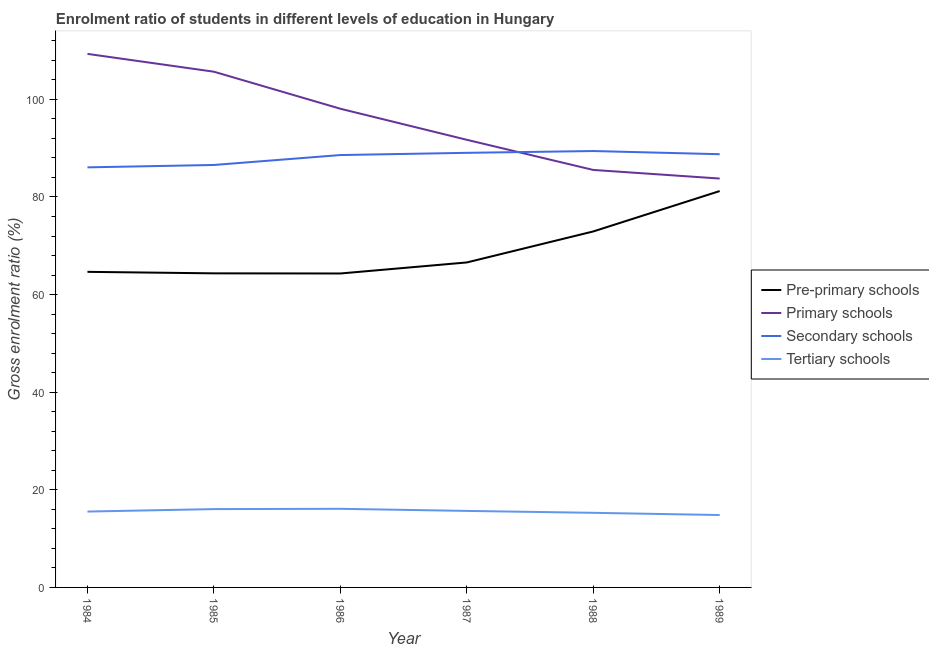Does the line corresponding to gross enrolment ratio in pre-primary schools intersect with the line corresponding to gross enrolment ratio in secondary schools?
Provide a succinct answer. No. Is the number of lines equal to the number of legend labels?
Provide a succinct answer. Yes. What is the gross enrolment ratio in tertiary schools in 1987?
Make the answer very short. 15.68. Across all years, what is the maximum gross enrolment ratio in secondary schools?
Offer a terse response. 89.41. Across all years, what is the minimum gross enrolment ratio in tertiary schools?
Offer a very short reply. 14.83. In which year was the gross enrolment ratio in tertiary schools maximum?
Your answer should be very brief. 1986. In which year was the gross enrolment ratio in secondary schools minimum?
Ensure brevity in your answer.  1984. What is the total gross enrolment ratio in secondary schools in the graph?
Give a very brief answer. 528.42. What is the difference between the gross enrolment ratio in tertiary schools in 1985 and that in 1987?
Provide a succinct answer. 0.37. What is the difference between the gross enrolment ratio in pre-primary schools in 1988 and the gross enrolment ratio in secondary schools in 1986?
Keep it short and to the point. -15.66. What is the average gross enrolment ratio in secondary schools per year?
Provide a succinct answer. 88.07. In the year 1988, what is the difference between the gross enrolment ratio in pre-primary schools and gross enrolment ratio in secondary schools?
Provide a short and direct response. -16.48. What is the ratio of the gross enrolment ratio in tertiary schools in 1986 to that in 1988?
Offer a very short reply. 1.05. Is the difference between the gross enrolment ratio in secondary schools in 1986 and 1988 greater than the difference between the gross enrolment ratio in tertiary schools in 1986 and 1988?
Offer a very short reply. No. What is the difference between the highest and the second highest gross enrolment ratio in pre-primary schools?
Provide a short and direct response. 8.28. What is the difference between the highest and the lowest gross enrolment ratio in tertiary schools?
Ensure brevity in your answer.  1.28. Is the sum of the gross enrolment ratio in tertiary schools in 1985 and 1988 greater than the maximum gross enrolment ratio in primary schools across all years?
Keep it short and to the point. No. Is it the case that in every year, the sum of the gross enrolment ratio in pre-primary schools and gross enrolment ratio in tertiary schools is greater than the sum of gross enrolment ratio in primary schools and gross enrolment ratio in secondary schools?
Your answer should be compact. Yes. Is it the case that in every year, the sum of the gross enrolment ratio in pre-primary schools and gross enrolment ratio in primary schools is greater than the gross enrolment ratio in secondary schools?
Provide a succinct answer. Yes. Does the gross enrolment ratio in secondary schools monotonically increase over the years?
Provide a succinct answer. No. Is the gross enrolment ratio in secondary schools strictly less than the gross enrolment ratio in tertiary schools over the years?
Provide a succinct answer. No. How many years are there in the graph?
Your answer should be very brief. 6. Does the graph contain any zero values?
Offer a very short reply. No. How many legend labels are there?
Provide a succinct answer. 4. What is the title of the graph?
Offer a very short reply. Enrolment ratio of students in different levels of education in Hungary. Does "France" appear as one of the legend labels in the graph?
Your answer should be compact. No. What is the label or title of the X-axis?
Offer a very short reply. Year. What is the Gross enrolment ratio (%) of Pre-primary schools in 1984?
Keep it short and to the point. 64.66. What is the Gross enrolment ratio (%) of Primary schools in 1984?
Offer a terse response. 109.31. What is the Gross enrolment ratio (%) of Secondary schools in 1984?
Offer a terse response. 86.07. What is the Gross enrolment ratio (%) of Tertiary schools in 1984?
Your response must be concise. 15.54. What is the Gross enrolment ratio (%) in Pre-primary schools in 1985?
Your response must be concise. 64.35. What is the Gross enrolment ratio (%) in Primary schools in 1985?
Ensure brevity in your answer.  105.66. What is the Gross enrolment ratio (%) of Secondary schools in 1985?
Ensure brevity in your answer.  86.55. What is the Gross enrolment ratio (%) in Tertiary schools in 1985?
Offer a terse response. 16.05. What is the Gross enrolment ratio (%) in Pre-primary schools in 1986?
Provide a succinct answer. 64.32. What is the Gross enrolment ratio (%) in Primary schools in 1986?
Offer a very short reply. 98.08. What is the Gross enrolment ratio (%) of Secondary schools in 1986?
Your answer should be compact. 88.59. What is the Gross enrolment ratio (%) of Tertiary schools in 1986?
Ensure brevity in your answer.  16.11. What is the Gross enrolment ratio (%) in Pre-primary schools in 1987?
Keep it short and to the point. 66.58. What is the Gross enrolment ratio (%) in Primary schools in 1987?
Give a very brief answer. 91.71. What is the Gross enrolment ratio (%) in Secondary schools in 1987?
Your answer should be compact. 89.04. What is the Gross enrolment ratio (%) of Tertiary schools in 1987?
Your response must be concise. 15.68. What is the Gross enrolment ratio (%) in Pre-primary schools in 1988?
Your answer should be compact. 72.93. What is the Gross enrolment ratio (%) of Primary schools in 1988?
Offer a terse response. 85.54. What is the Gross enrolment ratio (%) of Secondary schools in 1988?
Give a very brief answer. 89.41. What is the Gross enrolment ratio (%) in Tertiary schools in 1988?
Provide a succinct answer. 15.29. What is the Gross enrolment ratio (%) in Pre-primary schools in 1989?
Your response must be concise. 81.21. What is the Gross enrolment ratio (%) of Primary schools in 1989?
Offer a terse response. 83.77. What is the Gross enrolment ratio (%) of Secondary schools in 1989?
Your answer should be compact. 88.76. What is the Gross enrolment ratio (%) in Tertiary schools in 1989?
Give a very brief answer. 14.83. Across all years, what is the maximum Gross enrolment ratio (%) of Pre-primary schools?
Ensure brevity in your answer.  81.21. Across all years, what is the maximum Gross enrolment ratio (%) in Primary schools?
Ensure brevity in your answer.  109.31. Across all years, what is the maximum Gross enrolment ratio (%) in Secondary schools?
Provide a succinct answer. 89.41. Across all years, what is the maximum Gross enrolment ratio (%) of Tertiary schools?
Make the answer very short. 16.11. Across all years, what is the minimum Gross enrolment ratio (%) of Pre-primary schools?
Your response must be concise. 64.32. Across all years, what is the minimum Gross enrolment ratio (%) in Primary schools?
Make the answer very short. 83.77. Across all years, what is the minimum Gross enrolment ratio (%) in Secondary schools?
Your answer should be compact. 86.07. Across all years, what is the minimum Gross enrolment ratio (%) in Tertiary schools?
Offer a very short reply. 14.83. What is the total Gross enrolment ratio (%) of Pre-primary schools in the graph?
Give a very brief answer. 414.05. What is the total Gross enrolment ratio (%) in Primary schools in the graph?
Provide a short and direct response. 574.07. What is the total Gross enrolment ratio (%) in Secondary schools in the graph?
Offer a very short reply. 528.42. What is the total Gross enrolment ratio (%) in Tertiary schools in the graph?
Your answer should be very brief. 93.5. What is the difference between the Gross enrolment ratio (%) of Pre-primary schools in 1984 and that in 1985?
Give a very brief answer. 0.31. What is the difference between the Gross enrolment ratio (%) of Primary schools in 1984 and that in 1985?
Make the answer very short. 3.65. What is the difference between the Gross enrolment ratio (%) of Secondary schools in 1984 and that in 1985?
Give a very brief answer. -0.49. What is the difference between the Gross enrolment ratio (%) in Tertiary schools in 1984 and that in 1985?
Keep it short and to the point. -0.5. What is the difference between the Gross enrolment ratio (%) of Pre-primary schools in 1984 and that in 1986?
Give a very brief answer. 0.34. What is the difference between the Gross enrolment ratio (%) of Primary schools in 1984 and that in 1986?
Provide a short and direct response. 11.24. What is the difference between the Gross enrolment ratio (%) of Secondary schools in 1984 and that in 1986?
Keep it short and to the point. -2.52. What is the difference between the Gross enrolment ratio (%) of Tertiary schools in 1984 and that in 1986?
Your response must be concise. -0.56. What is the difference between the Gross enrolment ratio (%) of Pre-primary schools in 1984 and that in 1987?
Your response must be concise. -1.92. What is the difference between the Gross enrolment ratio (%) of Primary schools in 1984 and that in 1987?
Give a very brief answer. 17.6. What is the difference between the Gross enrolment ratio (%) in Secondary schools in 1984 and that in 1987?
Provide a short and direct response. -2.98. What is the difference between the Gross enrolment ratio (%) of Tertiary schools in 1984 and that in 1987?
Offer a terse response. -0.14. What is the difference between the Gross enrolment ratio (%) of Pre-primary schools in 1984 and that in 1988?
Keep it short and to the point. -8.27. What is the difference between the Gross enrolment ratio (%) of Primary schools in 1984 and that in 1988?
Your answer should be compact. 23.78. What is the difference between the Gross enrolment ratio (%) in Secondary schools in 1984 and that in 1988?
Your response must be concise. -3.34. What is the difference between the Gross enrolment ratio (%) in Tertiary schools in 1984 and that in 1988?
Give a very brief answer. 0.26. What is the difference between the Gross enrolment ratio (%) in Pre-primary schools in 1984 and that in 1989?
Your answer should be very brief. -16.55. What is the difference between the Gross enrolment ratio (%) in Primary schools in 1984 and that in 1989?
Provide a succinct answer. 25.54. What is the difference between the Gross enrolment ratio (%) of Secondary schools in 1984 and that in 1989?
Your answer should be compact. -2.69. What is the difference between the Gross enrolment ratio (%) in Tertiary schools in 1984 and that in 1989?
Keep it short and to the point. 0.71. What is the difference between the Gross enrolment ratio (%) in Pre-primary schools in 1985 and that in 1986?
Give a very brief answer. 0.03. What is the difference between the Gross enrolment ratio (%) of Primary schools in 1985 and that in 1986?
Make the answer very short. 7.59. What is the difference between the Gross enrolment ratio (%) of Secondary schools in 1985 and that in 1986?
Keep it short and to the point. -2.03. What is the difference between the Gross enrolment ratio (%) of Tertiary schools in 1985 and that in 1986?
Give a very brief answer. -0.06. What is the difference between the Gross enrolment ratio (%) of Pre-primary schools in 1985 and that in 1987?
Your answer should be compact. -2.23. What is the difference between the Gross enrolment ratio (%) of Primary schools in 1985 and that in 1987?
Make the answer very short. 13.95. What is the difference between the Gross enrolment ratio (%) of Secondary schools in 1985 and that in 1987?
Offer a terse response. -2.49. What is the difference between the Gross enrolment ratio (%) of Tertiary schools in 1985 and that in 1987?
Offer a terse response. 0.37. What is the difference between the Gross enrolment ratio (%) in Pre-primary schools in 1985 and that in 1988?
Offer a terse response. -8.58. What is the difference between the Gross enrolment ratio (%) of Primary schools in 1985 and that in 1988?
Ensure brevity in your answer.  20.13. What is the difference between the Gross enrolment ratio (%) in Secondary schools in 1985 and that in 1988?
Provide a succinct answer. -2.86. What is the difference between the Gross enrolment ratio (%) of Tertiary schools in 1985 and that in 1988?
Your answer should be compact. 0.76. What is the difference between the Gross enrolment ratio (%) of Pre-primary schools in 1985 and that in 1989?
Provide a short and direct response. -16.86. What is the difference between the Gross enrolment ratio (%) in Primary schools in 1985 and that in 1989?
Offer a terse response. 21.89. What is the difference between the Gross enrolment ratio (%) of Secondary schools in 1985 and that in 1989?
Provide a short and direct response. -2.2. What is the difference between the Gross enrolment ratio (%) in Tertiary schools in 1985 and that in 1989?
Your answer should be very brief. 1.22. What is the difference between the Gross enrolment ratio (%) in Pre-primary schools in 1986 and that in 1987?
Ensure brevity in your answer.  -2.26. What is the difference between the Gross enrolment ratio (%) of Primary schools in 1986 and that in 1987?
Give a very brief answer. 6.36. What is the difference between the Gross enrolment ratio (%) of Secondary schools in 1986 and that in 1987?
Provide a succinct answer. -0.46. What is the difference between the Gross enrolment ratio (%) in Tertiary schools in 1986 and that in 1987?
Your answer should be very brief. 0.43. What is the difference between the Gross enrolment ratio (%) of Pre-primary schools in 1986 and that in 1988?
Make the answer very short. -8.61. What is the difference between the Gross enrolment ratio (%) in Primary schools in 1986 and that in 1988?
Give a very brief answer. 12.54. What is the difference between the Gross enrolment ratio (%) in Secondary schools in 1986 and that in 1988?
Provide a short and direct response. -0.82. What is the difference between the Gross enrolment ratio (%) of Tertiary schools in 1986 and that in 1988?
Ensure brevity in your answer.  0.82. What is the difference between the Gross enrolment ratio (%) of Pre-primary schools in 1986 and that in 1989?
Your answer should be compact. -16.89. What is the difference between the Gross enrolment ratio (%) in Primary schools in 1986 and that in 1989?
Make the answer very short. 14.3. What is the difference between the Gross enrolment ratio (%) of Secondary schools in 1986 and that in 1989?
Provide a short and direct response. -0.17. What is the difference between the Gross enrolment ratio (%) in Tertiary schools in 1986 and that in 1989?
Your answer should be compact. 1.28. What is the difference between the Gross enrolment ratio (%) of Pre-primary schools in 1987 and that in 1988?
Provide a succinct answer. -6.35. What is the difference between the Gross enrolment ratio (%) of Primary schools in 1987 and that in 1988?
Your response must be concise. 6.17. What is the difference between the Gross enrolment ratio (%) of Secondary schools in 1987 and that in 1988?
Your response must be concise. -0.37. What is the difference between the Gross enrolment ratio (%) in Tertiary schools in 1987 and that in 1988?
Give a very brief answer. 0.39. What is the difference between the Gross enrolment ratio (%) of Pre-primary schools in 1987 and that in 1989?
Offer a terse response. -14.63. What is the difference between the Gross enrolment ratio (%) of Primary schools in 1987 and that in 1989?
Make the answer very short. 7.94. What is the difference between the Gross enrolment ratio (%) of Secondary schools in 1987 and that in 1989?
Your answer should be compact. 0.28. What is the difference between the Gross enrolment ratio (%) in Tertiary schools in 1987 and that in 1989?
Ensure brevity in your answer.  0.85. What is the difference between the Gross enrolment ratio (%) of Pre-primary schools in 1988 and that in 1989?
Provide a short and direct response. -8.28. What is the difference between the Gross enrolment ratio (%) in Primary schools in 1988 and that in 1989?
Make the answer very short. 1.76. What is the difference between the Gross enrolment ratio (%) in Secondary schools in 1988 and that in 1989?
Provide a short and direct response. 0.65. What is the difference between the Gross enrolment ratio (%) in Tertiary schools in 1988 and that in 1989?
Provide a short and direct response. 0.46. What is the difference between the Gross enrolment ratio (%) of Pre-primary schools in 1984 and the Gross enrolment ratio (%) of Primary schools in 1985?
Your answer should be very brief. -41. What is the difference between the Gross enrolment ratio (%) in Pre-primary schools in 1984 and the Gross enrolment ratio (%) in Secondary schools in 1985?
Keep it short and to the point. -21.9. What is the difference between the Gross enrolment ratio (%) of Pre-primary schools in 1984 and the Gross enrolment ratio (%) of Tertiary schools in 1985?
Your response must be concise. 48.61. What is the difference between the Gross enrolment ratio (%) of Primary schools in 1984 and the Gross enrolment ratio (%) of Secondary schools in 1985?
Your response must be concise. 22.76. What is the difference between the Gross enrolment ratio (%) of Primary schools in 1984 and the Gross enrolment ratio (%) of Tertiary schools in 1985?
Provide a short and direct response. 93.27. What is the difference between the Gross enrolment ratio (%) of Secondary schools in 1984 and the Gross enrolment ratio (%) of Tertiary schools in 1985?
Your response must be concise. 70.02. What is the difference between the Gross enrolment ratio (%) in Pre-primary schools in 1984 and the Gross enrolment ratio (%) in Primary schools in 1986?
Provide a succinct answer. -33.42. What is the difference between the Gross enrolment ratio (%) in Pre-primary schools in 1984 and the Gross enrolment ratio (%) in Secondary schools in 1986?
Keep it short and to the point. -23.93. What is the difference between the Gross enrolment ratio (%) in Pre-primary schools in 1984 and the Gross enrolment ratio (%) in Tertiary schools in 1986?
Your response must be concise. 48.55. What is the difference between the Gross enrolment ratio (%) of Primary schools in 1984 and the Gross enrolment ratio (%) of Secondary schools in 1986?
Keep it short and to the point. 20.73. What is the difference between the Gross enrolment ratio (%) in Primary schools in 1984 and the Gross enrolment ratio (%) in Tertiary schools in 1986?
Your response must be concise. 93.21. What is the difference between the Gross enrolment ratio (%) of Secondary schools in 1984 and the Gross enrolment ratio (%) of Tertiary schools in 1986?
Ensure brevity in your answer.  69.96. What is the difference between the Gross enrolment ratio (%) in Pre-primary schools in 1984 and the Gross enrolment ratio (%) in Primary schools in 1987?
Keep it short and to the point. -27.05. What is the difference between the Gross enrolment ratio (%) of Pre-primary schools in 1984 and the Gross enrolment ratio (%) of Secondary schools in 1987?
Provide a short and direct response. -24.38. What is the difference between the Gross enrolment ratio (%) in Pre-primary schools in 1984 and the Gross enrolment ratio (%) in Tertiary schools in 1987?
Your answer should be compact. 48.98. What is the difference between the Gross enrolment ratio (%) of Primary schools in 1984 and the Gross enrolment ratio (%) of Secondary schools in 1987?
Offer a very short reply. 20.27. What is the difference between the Gross enrolment ratio (%) of Primary schools in 1984 and the Gross enrolment ratio (%) of Tertiary schools in 1987?
Provide a succinct answer. 93.64. What is the difference between the Gross enrolment ratio (%) of Secondary schools in 1984 and the Gross enrolment ratio (%) of Tertiary schools in 1987?
Offer a very short reply. 70.39. What is the difference between the Gross enrolment ratio (%) of Pre-primary schools in 1984 and the Gross enrolment ratio (%) of Primary schools in 1988?
Your response must be concise. -20.88. What is the difference between the Gross enrolment ratio (%) of Pre-primary schools in 1984 and the Gross enrolment ratio (%) of Secondary schools in 1988?
Provide a short and direct response. -24.75. What is the difference between the Gross enrolment ratio (%) of Pre-primary schools in 1984 and the Gross enrolment ratio (%) of Tertiary schools in 1988?
Your response must be concise. 49.37. What is the difference between the Gross enrolment ratio (%) in Primary schools in 1984 and the Gross enrolment ratio (%) in Secondary schools in 1988?
Your answer should be compact. 19.9. What is the difference between the Gross enrolment ratio (%) of Primary schools in 1984 and the Gross enrolment ratio (%) of Tertiary schools in 1988?
Provide a short and direct response. 94.03. What is the difference between the Gross enrolment ratio (%) in Secondary schools in 1984 and the Gross enrolment ratio (%) in Tertiary schools in 1988?
Your answer should be very brief. 70.78. What is the difference between the Gross enrolment ratio (%) in Pre-primary schools in 1984 and the Gross enrolment ratio (%) in Primary schools in 1989?
Provide a succinct answer. -19.11. What is the difference between the Gross enrolment ratio (%) of Pre-primary schools in 1984 and the Gross enrolment ratio (%) of Secondary schools in 1989?
Your response must be concise. -24.1. What is the difference between the Gross enrolment ratio (%) of Pre-primary schools in 1984 and the Gross enrolment ratio (%) of Tertiary schools in 1989?
Offer a terse response. 49.83. What is the difference between the Gross enrolment ratio (%) of Primary schools in 1984 and the Gross enrolment ratio (%) of Secondary schools in 1989?
Ensure brevity in your answer.  20.56. What is the difference between the Gross enrolment ratio (%) of Primary schools in 1984 and the Gross enrolment ratio (%) of Tertiary schools in 1989?
Provide a succinct answer. 94.48. What is the difference between the Gross enrolment ratio (%) of Secondary schools in 1984 and the Gross enrolment ratio (%) of Tertiary schools in 1989?
Ensure brevity in your answer.  71.24. What is the difference between the Gross enrolment ratio (%) of Pre-primary schools in 1985 and the Gross enrolment ratio (%) of Primary schools in 1986?
Provide a short and direct response. -33.73. What is the difference between the Gross enrolment ratio (%) of Pre-primary schools in 1985 and the Gross enrolment ratio (%) of Secondary schools in 1986?
Provide a short and direct response. -24.24. What is the difference between the Gross enrolment ratio (%) of Pre-primary schools in 1985 and the Gross enrolment ratio (%) of Tertiary schools in 1986?
Ensure brevity in your answer.  48.24. What is the difference between the Gross enrolment ratio (%) in Primary schools in 1985 and the Gross enrolment ratio (%) in Secondary schools in 1986?
Your response must be concise. 17.08. What is the difference between the Gross enrolment ratio (%) in Primary schools in 1985 and the Gross enrolment ratio (%) in Tertiary schools in 1986?
Your answer should be very brief. 89.56. What is the difference between the Gross enrolment ratio (%) in Secondary schools in 1985 and the Gross enrolment ratio (%) in Tertiary schools in 1986?
Provide a short and direct response. 70.45. What is the difference between the Gross enrolment ratio (%) of Pre-primary schools in 1985 and the Gross enrolment ratio (%) of Primary schools in 1987?
Provide a succinct answer. -27.36. What is the difference between the Gross enrolment ratio (%) in Pre-primary schools in 1985 and the Gross enrolment ratio (%) in Secondary schools in 1987?
Your answer should be compact. -24.69. What is the difference between the Gross enrolment ratio (%) in Pre-primary schools in 1985 and the Gross enrolment ratio (%) in Tertiary schools in 1987?
Offer a terse response. 48.67. What is the difference between the Gross enrolment ratio (%) of Primary schools in 1985 and the Gross enrolment ratio (%) of Secondary schools in 1987?
Your answer should be compact. 16.62. What is the difference between the Gross enrolment ratio (%) in Primary schools in 1985 and the Gross enrolment ratio (%) in Tertiary schools in 1987?
Offer a very short reply. 89.98. What is the difference between the Gross enrolment ratio (%) in Secondary schools in 1985 and the Gross enrolment ratio (%) in Tertiary schools in 1987?
Offer a very short reply. 70.88. What is the difference between the Gross enrolment ratio (%) in Pre-primary schools in 1985 and the Gross enrolment ratio (%) in Primary schools in 1988?
Ensure brevity in your answer.  -21.19. What is the difference between the Gross enrolment ratio (%) in Pre-primary schools in 1985 and the Gross enrolment ratio (%) in Secondary schools in 1988?
Make the answer very short. -25.06. What is the difference between the Gross enrolment ratio (%) in Pre-primary schools in 1985 and the Gross enrolment ratio (%) in Tertiary schools in 1988?
Your response must be concise. 49.06. What is the difference between the Gross enrolment ratio (%) in Primary schools in 1985 and the Gross enrolment ratio (%) in Secondary schools in 1988?
Your response must be concise. 16.25. What is the difference between the Gross enrolment ratio (%) of Primary schools in 1985 and the Gross enrolment ratio (%) of Tertiary schools in 1988?
Ensure brevity in your answer.  90.38. What is the difference between the Gross enrolment ratio (%) in Secondary schools in 1985 and the Gross enrolment ratio (%) in Tertiary schools in 1988?
Your answer should be compact. 71.27. What is the difference between the Gross enrolment ratio (%) in Pre-primary schools in 1985 and the Gross enrolment ratio (%) in Primary schools in 1989?
Your response must be concise. -19.42. What is the difference between the Gross enrolment ratio (%) in Pre-primary schools in 1985 and the Gross enrolment ratio (%) in Secondary schools in 1989?
Your answer should be very brief. -24.41. What is the difference between the Gross enrolment ratio (%) in Pre-primary schools in 1985 and the Gross enrolment ratio (%) in Tertiary schools in 1989?
Your response must be concise. 49.52. What is the difference between the Gross enrolment ratio (%) of Primary schools in 1985 and the Gross enrolment ratio (%) of Secondary schools in 1989?
Your answer should be very brief. 16.9. What is the difference between the Gross enrolment ratio (%) in Primary schools in 1985 and the Gross enrolment ratio (%) in Tertiary schools in 1989?
Offer a terse response. 90.83. What is the difference between the Gross enrolment ratio (%) of Secondary schools in 1985 and the Gross enrolment ratio (%) of Tertiary schools in 1989?
Provide a short and direct response. 71.72. What is the difference between the Gross enrolment ratio (%) of Pre-primary schools in 1986 and the Gross enrolment ratio (%) of Primary schools in 1987?
Your response must be concise. -27.39. What is the difference between the Gross enrolment ratio (%) of Pre-primary schools in 1986 and the Gross enrolment ratio (%) of Secondary schools in 1987?
Keep it short and to the point. -24.72. What is the difference between the Gross enrolment ratio (%) in Pre-primary schools in 1986 and the Gross enrolment ratio (%) in Tertiary schools in 1987?
Your response must be concise. 48.64. What is the difference between the Gross enrolment ratio (%) in Primary schools in 1986 and the Gross enrolment ratio (%) in Secondary schools in 1987?
Give a very brief answer. 9.03. What is the difference between the Gross enrolment ratio (%) in Primary schools in 1986 and the Gross enrolment ratio (%) in Tertiary schools in 1987?
Give a very brief answer. 82.4. What is the difference between the Gross enrolment ratio (%) in Secondary schools in 1986 and the Gross enrolment ratio (%) in Tertiary schools in 1987?
Make the answer very short. 72.91. What is the difference between the Gross enrolment ratio (%) of Pre-primary schools in 1986 and the Gross enrolment ratio (%) of Primary schools in 1988?
Offer a very short reply. -21.21. What is the difference between the Gross enrolment ratio (%) in Pre-primary schools in 1986 and the Gross enrolment ratio (%) in Secondary schools in 1988?
Give a very brief answer. -25.09. What is the difference between the Gross enrolment ratio (%) in Pre-primary schools in 1986 and the Gross enrolment ratio (%) in Tertiary schools in 1988?
Your response must be concise. 49.04. What is the difference between the Gross enrolment ratio (%) in Primary schools in 1986 and the Gross enrolment ratio (%) in Secondary schools in 1988?
Your answer should be compact. 8.67. What is the difference between the Gross enrolment ratio (%) of Primary schools in 1986 and the Gross enrolment ratio (%) of Tertiary schools in 1988?
Keep it short and to the point. 82.79. What is the difference between the Gross enrolment ratio (%) of Secondary schools in 1986 and the Gross enrolment ratio (%) of Tertiary schools in 1988?
Your answer should be compact. 73.3. What is the difference between the Gross enrolment ratio (%) of Pre-primary schools in 1986 and the Gross enrolment ratio (%) of Primary schools in 1989?
Keep it short and to the point. -19.45. What is the difference between the Gross enrolment ratio (%) in Pre-primary schools in 1986 and the Gross enrolment ratio (%) in Secondary schools in 1989?
Your answer should be very brief. -24.44. What is the difference between the Gross enrolment ratio (%) in Pre-primary schools in 1986 and the Gross enrolment ratio (%) in Tertiary schools in 1989?
Keep it short and to the point. 49.49. What is the difference between the Gross enrolment ratio (%) in Primary schools in 1986 and the Gross enrolment ratio (%) in Secondary schools in 1989?
Your answer should be compact. 9.32. What is the difference between the Gross enrolment ratio (%) in Primary schools in 1986 and the Gross enrolment ratio (%) in Tertiary schools in 1989?
Ensure brevity in your answer.  83.24. What is the difference between the Gross enrolment ratio (%) in Secondary schools in 1986 and the Gross enrolment ratio (%) in Tertiary schools in 1989?
Provide a succinct answer. 73.76. What is the difference between the Gross enrolment ratio (%) of Pre-primary schools in 1987 and the Gross enrolment ratio (%) of Primary schools in 1988?
Your answer should be compact. -18.95. What is the difference between the Gross enrolment ratio (%) in Pre-primary schools in 1987 and the Gross enrolment ratio (%) in Secondary schools in 1988?
Provide a succinct answer. -22.83. What is the difference between the Gross enrolment ratio (%) in Pre-primary schools in 1987 and the Gross enrolment ratio (%) in Tertiary schools in 1988?
Provide a succinct answer. 51.3. What is the difference between the Gross enrolment ratio (%) in Primary schools in 1987 and the Gross enrolment ratio (%) in Secondary schools in 1988?
Offer a terse response. 2.3. What is the difference between the Gross enrolment ratio (%) of Primary schools in 1987 and the Gross enrolment ratio (%) of Tertiary schools in 1988?
Offer a terse response. 76.42. What is the difference between the Gross enrolment ratio (%) in Secondary schools in 1987 and the Gross enrolment ratio (%) in Tertiary schools in 1988?
Your answer should be compact. 73.76. What is the difference between the Gross enrolment ratio (%) of Pre-primary schools in 1987 and the Gross enrolment ratio (%) of Primary schools in 1989?
Provide a succinct answer. -17.19. What is the difference between the Gross enrolment ratio (%) of Pre-primary schools in 1987 and the Gross enrolment ratio (%) of Secondary schools in 1989?
Make the answer very short. -22.18. What is the difference between the Gross enrolment ratio (%) of Pre-primary schools in 1987 and the Gross enrolment ratio (%) of Tertiary schools in 1989?
Offer a terse response. 51.75. What is the difference between the Gross enrolment ratio (%) of Primary schools in 1987 and the Gross enrolment ratio (%) of Secondary schools in 1989?
Your answer should be very brief. 2.95. What is the difference between the Gross enrolment ratio (%) of Primary schools in 1987 and the Gross enrolment ratio (%) of Tertiary schools in 1989?
Your answer should be very brief. 76.88. What is the difference between the Gross enrolment ratio (%) in Secondary schools in 1987 and the Gross enrolment ratio (%) in Tertiary schools in 1989?
Your response must be concise. 74.21. What is the difference between the Gross enrolment ratio (%) in Pre-primary schools in 1988 and the Gross enrolment ratio (%) in Primary schools in 1989?
Provide a succinct answer. -10.84. What is the difference between the Gross enrolment ratio (%) of Pre-primary schools in 1988 and the Gross enrolment ratio (%) of Secondary schools in 1989?
Your answer should be compact. -15.83. What is the difference between the Gross enrolment ratio (%) in Pre-primary schools in 1988 and the Gross enrolment ratio (%) in Tertiary schools in 1989?
Give a very brief answer. 58.1. What is the difference between the Gross enrolment ratio (%) in Primary schools in 1988 and the Gross enrolment ratio (%) in Secondary schools in 1989?
Make the answer very short. -3.22. What is the difference between the Gross enrolment ratio (%) in Primary schools in 1988 and the Gross enrolment ratio (%) in Tertiary schools in 1989?
Make the answer very short. 70.71. What is the difference between the Gross enrolment ratio (%) in Secondary schools in 1988 and the Gross enrolment ratio (%) in Tertiary schools in 1989?
Provide a succinct answer. 74.58. What is the average Gross enrolment ratio (%) of Pre-primary schools per year?
Your answer should be very brief. 69.01. What is the average Gross enrolment ratio (%) in Primary schools per year?
Offer a very short reply. 95.68. What is the average Gross enrolment ratio (%) of Secondary schools per year?
Your answer should be very brief. 88.07. What is the average Gross enrolment ratio (%) of Tertiary schools per year?
Offer a very short reply. 15.58. In the year 1984, what is the difference between the Gross enrolment ratio (%) in Pre-primary schools and Gross enrolment ratio (%) in Primary schools?
Your answer should be very brief. -44.66. In the year 1984, what is the difference between the Gross enrolment ratio (%) in Pre-primary schools and Gross enrolment ratio (%) in Secondary schools?
Your answer should be compact. -21.41. In the year 1984, what is the difference between the Gross enrolment ratio (%) in Pre-primary schools and Gross enrolment ratio (%) in Tertiary schools?
Keep it short and to the point. 49.12. In the year 1984, what is the difference between the Gross enrolment ratio (%) in Primary schools and Gross enrolment ratio (%) in Secondary schools?
Provide a succinct answer. 23.25. In the year 1984, what is the difference between the Gross enrolment ratio (%) in Primary schools and Gross enrolment ratio (%) in Tertiary schools?
Provide a short and direct response. 93.77. In the year 1984, what is the difference between the Gross enrolment ratio (%) of Secondary schools and Gross enrolment ratio (%) of Tertiary schools?
Your response must be concise. 70.52. In the year 1985, what is the difference between the Gross enrolment ratio (%) of Pre-primary schools and Gross enrolment ratio (%) of Primary schools?
Offer a very short reply. -41.31. In the year 1985, what is the difference between the Gross enrolment ratio (%) of Pre-primary schools and Gross enrolment ratio (%) of Secondary schools?
Make the answer very short. -22.21. In the year 1985, what is the difference between the Gross enrolment ratio (%) of Pre-primary schools and Gross enrolment ratio (%) of Tertiary schools?
Make the answer very short. 48.3. In the year 1985, what is the difference between the Gross enrolment ratio (%) of Primary schools and Gross enrolment ratio (%) of Secondary schools?
Make the answer very short. 19.11. In the year 1985, what is the difference between the Gross enrolment ratio (%) of Primary schools and Gross enrolment ratio (%) of Tertiary schools?
Give a very brief answer. 89.61. In the year 1985, what is the difference between the Gross enrolment ratio (%) in Secondary schools and Gross enrolment ratio (%) in Tertiary schools?
Offer a very short reply. 70.51. In the year 1986, what is the difference between the Gross enrolment ratio (%) of Pre-primary schools and Gross enrolment ratio (%) of Primary schools?
Offer a very short reply. -33.75. In the year 1986, what is the difference between the Gross enrolment ratio (%) in Pre-primary schools and Gross enrolment ratio (%) in Secondary schools?
Offer a very short reply. -24.27. In the year 1986, what is the difference between the Gross enrolment ratio (%) in Pre-primary schools and Gross enrolment ratio (%) in Tertiary schools?
Provide a succinct answer. 48.21. In the year 1986, what is the difference between the Gross enrolment ratio (%) in Primary schools and Gross enrolment ratio (%) in Secondary schools?
Offer a terse response. 9.49. In the year 1986, what is the difference between the Gross enrolment ratio (%) in Primary schools and Gross enrolment ratio (%) in Tertiary schools?
Offer a terse response. 81.97. In the year 1986, what is the difference between the Gross enrolment ratio (%) in Secondary schools and Gross enrolment ratio (%) in Tertiary schools?
Your answer should be very brief. 72.48. In the year 1987, what is the difference between the Gross enrolment ratio (%) of Pre-primary schools and Gross enrolment ratio (%) of Primary schools?
Your response must be concise. -25.13. In the year 1987, what is the difference between the Gross enrolment ratio (%) in Pre-primary schools and Gross enrolment ratio (%) in Secondary schools?
Your answer should be very brief. -22.46. In the year 1987, what is the difference between the Gross enrolment ratio (%) of Pre-primary schools and Gross enrolment ratio (%) of Tertiary schools?
Give a very brief answer. 50.9. In the year 1987, what is the difference between the Gross enrolment ratio (%) of Primary schools and Gross enrolment ratio (%) of Secondary schools?
Your answer should be compact. 2.67. In the year 1987, what is the difference between the Gross enrolment ratio (%) in Primary schools and Gross enrolment ratio (%) in Tertiary schools?
Give a very brief answer. 76.03. In the year 1987, what is the difference between the Gross enrolment ratio (%) in Secondary schools and Gross enrolment ratio (%) in Tertiary schools?
Provide a succinct answer. 73.36. In the year 1988, what is the difference between the Gross enrolment ratio (%) in Pre-primary schools and Gross enrolment ratio (%) in Primary schools?
Make the answer very short. -12.6. In the year 1988, what is the difference between the Gross enrolment ratio (%) of Pre-primary schools and Gross enrolment ratio (%) of Secondary schools?
Provide a succinct answer. -16.48. In the year 1988, what is the difference between the Gross enrolment ratio (%) in Pre-primary schools and Gross enrolment ratio (%) in Tertiary schools?
Provide a short and direct response. 57.65. In the year 1988, what is the difference between the Gross enrolment ratio (%) of Primary schools and Gross enrolment ratio (%) of Secondary schools?
Keep it short and to the point. -3.87. In the year 1988, what is the difference between the Gross enrolment ratio (%) in Primary schools and Gross enrolment ratio (%) in Tertiary schools?
Make the answer very short. 70.25. In the year 1988, what is the difference between the Gross enrolment ratio (%) in Secondary schools and Gross enrolment ratio (%) in Tertiary schools?
Keep it short and to the point. 74.12. In the year 1989, what is the difference between the Gross enrolment ratio (%) in Pre-primary schools and Gross enrolment ratio (%) in Primary schools?
Your response must be concise. -2.56. In the year 1989, what is the difference between the Gross enrolment ratio (%) of Pre-primary schools and Gross enrolment ratio (%) of Secondary schools?
Provide a short and direct response. -7.55. In the year 1989, what is the difference between the Gross enrolment ratio (%) in Pre-primary schools and Gross enrolment ratio (%) in Tertiary schools?
Give a very brief answer. 66.38. In the year 1989, what is the difference between the Gross enrolment ratio (%) in Primary schools and Gross enrolment ratio (%) in Secondary schools?
Ensure brevity in your answer.  -4.99. In the year 1989, what is the difference between the Gross enrolment ratio (%) of Primary schools and Gross enrolment ratio (%) of Tertiary schools?
Offer a terse response. 68.94. In the year 1989, what is the difference between the Gross enrolment ratio (%) in Secondary schools and Gross enrolment ratio (%) in Tertiary schools?
Your response must be concise. 73.93. What is the ratio of the Gross enrolment ratio (%) of Primary schools in 1984 to that in 1985?
Provide a short and direct response. 1.03. What is the ratio of the Gross enrolment ratio (%) of Tertiary schools in 1984 to that in 1985?
Offer a terse response. 0.97. What is the ratio of the Gross enrolment ratio (%) in Primary schools in 1984 to that in 1986?
Your response must be concise. 1.11. What is the ratio of the Gross enrolment ratio (%) of Secondary schools in 1984 to that in 1986?
Offer a very short reply. 0.97. What is the ratio of the Gross enrolment ratio (%) in Pre-primary schools in 1984 to that in 1987?
Provide a short and direct response. 0.97. What is the ratio of the Gross enrolment ratio (%) of Primary schools in 1984 to that in 1987?
Make the answer very short. 1.19. What is the ratio of the Gross enrolment ratio (%) in Secondary schools in 1984 to that in 1987?
Provide a short and direct response. 0.97. What is the ratio of the Gross enrolment ratio (%) in Pre-primary schools in 1984 to that in 1988?
Your answer should be very brief. 0.89. What is the ratio of the Gross enrolment ratio (%) of Primary schools in 1984 to that in 1988?
Provide a succinct answer. 1.28. What is the ratio of the Gross enrolment ratio (%) in Secondary schools in 1984 to that in 1988?
Your answer should be compact. 0.96. What is the ratio of the Gross enrolment ratio (%) in Tertiary schools in 1984 to that in 1988?
Provide a short and direct response. 1.02. What is the ratio of the Gross enrolment ratio (%) in Pre-primary schools in 1984 to that in 1989?
Give a very brief answer. 0.8. What is the ratio of the Gross enrolment ratio (%) in Primary schools in 1984 to that in 1989?
Provide a succinct answer. 1.3. What is the ratio of the Gross enrolment ratio (%) in Secondary schools in 1984 to that in 1989?
Your response must be concise. 0.97. What is the ratio of the Gross enrolment ratio (%) in Tertiary schools in 1984 to that in 1989?
Provide a succinct answer. 1.05. What is the ratio of the Gross enrolment ratio (%) in Primary schools in 1985 to that in 1986?
Keep it short and to the point. 1.08. What is the ratio of the Gross enrolment ratio (%) in Secondary schools in 1985 to that in 1986?
Offer a very short reply. 0.98. What is the ratio of the Gross enrolment ratio (%) of Tertiary schools in 1985 to that in 1986?
Your answer should be compact. 1. What is the ratio of the Gross enrolment ratio (%) in Pre-primary schools in 1985 to that in 1987?
Offer a terse response. 0.97. What is the ratio of the Gross enrolment ratio (%) of Primary schools in 1985 to that in 1987?
Your response must be concise. 1.15. What is the ratio of the Gross enrolment ratio (%) of Secondary schools in 1985 to that in 1987?
Ensure brevity in your answer.  0.97. What is the ratio of the Gross enrolment ratio (%) in Tertiary schools in 1985 to that in 1987?
Offer a very short reply. 1.02. What is the ratio of the Gross enrolment ratio (%) in Pre-primary schools in 1985 to that in 1988?
Provide a succinct answer. 0.88. What is the ratio of the Gross enrolment ratio (%) of Primary schools in 1985 to that in 1988?
Your answer should be compact. 1.24. What is the ratio of the Gross enrolment ratio (%) of Secondary schools in 1985 to that in 1988?
Ensure brevity in your answer.  0.97. What is the ratio of the Gross enrolment ratio (%) in Tertiary schools in 1985 to that in 1988?
Keep it short and to the point. 1.05. What is the ratio of the Gross enrolment ratio (%) of Pre-primary schools in 1985 to that in 1989?
Provide a short and direct response. 0.79. What is the ratio of the Gross enrolment ratio (%) in Primary schools in 1985 to that in 1989?
Offer a very short reply. 1.26. What is the ratio of the Gross enrolment ratio (%) of Secondary schools in 1985 to that in 1989?
Offer a terse response. 0.98. What is the ratio of the Gross enrolment ratio (%) in Tertiary schools in 1985 to that in 1989?
Keep it short and to the point. 1.08. What is the ratio of the Gross enrolment ratio (%) in Primary schools in 1986 to that in 1987?
Provide a succinct answer. 1.07. What is the ratio of the Gross enrolment ratio (%) in Secondary schools in 1986 to that in 1987?
Offer a terse response. 0.99. What is the ratio of the Gross enrolment ratio (%) of Tertiary schools in 1986 to that in 1987?
Your response must be concise. 1.03. What is the ratio of the Gross enrolment ratio (%) of Pre-primary schools in 1986 to that in 1988?
Provide a short and direct response. 0.88. What is the ratio of the Gross enrolment ratio (%) of Primary schools in 1986 to that in 1988?
Your answer should be compact. 1.15. What is the ratio of the Gross enrolment ratio (%) of Secondary schools in 1986 to that in 1988?
Your answer should be compact. 0.99. What is the ratio of the Gross enrolment ratio (%) of Tertiary schools in 1986 to that in 1988?
Give a very brief answer. 1.05. What is the ratio of the Gross enrolment ratio (%) in Pre-primary schools in 1986 to that in 1989?
Your answer should be compact. 0.79. What is the ratio of the Gross enrolment ratio (%) of Primary schools in 1986 to that in 1989?
Offer a terse response. 1.17. What is the ratio of the Gross enrolment ratio (%) of Secondary schools in 1986 to that in 1989?
Provide a succinct answer. 1. What is the ratio of the Gross enrolment ratio (%) in Tertiary schools in 1986 to that in 1989?
Keep it short and to the point. 1.09. What is the ratio of the Gross enrolment ratio (%) in Pre-primary schools in 1987 to that in 1988?
Offer a very short reply. 0.91. What is the ratio of the Gross enrolment ratio (%) of Primary schools in 1987 to that in 1988?
Make the answer very short. 1.07. What is the ratio of the Gross enrolment ratio (%) of Secondary schools in 1987 to that in 1988?
Keep it short and to the point. 1. What is the ratio of the Gross enrolment ratio (%) of Tertiary schools in 1987 to that in 1988?
Provide a short and direct response. 1.03. What is the ratio of the Gross enrolment ratio (%) in Pre-primary schools in 1987 to that in 1989?
Provide a succinct answer. 0.82. What is the ratio of the Gross enrolment ratio (%) in Primary schools in 1987 to that in 1989?
Ensure brevity in your answer.  1.09. What is the ratio of the Gross enrolment ratio (%) of Tertiary schools in 1987 to that in 1989?
Your answer should be compact. 1.06. What is the ratio of the Gross enrolment ratio (%) in Pre-primary schools in 1988 to that in 1989?
Ensure brevity in your answer.  0.9. What is the ratio of the Gross enrolment ratio (%) in Secondary schools in 1988 to that in 1989?
Keep it short and to the point. 1.01. What is the ratio of the Gross enrolment ratio (%) in Tertiary schools in 1988 to that in 1989?
Your response must be concise. 1.03. What is the difference between the highest and the second highest Gross enrolment ratio (%) in Pre-primary schools?
Your answer should be compact. 8.28. What is the difference between the highest and the second highest Gross enrolment ratio (%) in Primary schools?
Give a very brief answer. 3.65. What is the difference between the highest and the second highest Gross enrolment ratio (%) of Secondary schools?
Give a very brief answer. 0.37. What is the difference between the highest and the second highest Gross enrolment ratio (%) in Tertiary schools?
Provide a short and direct response. 0.06. What is the difference between the highest and the lowest Gross enrolment ratio (%) of Pre-primary schools?
Offer a terse response. 16.89. What is the difference between the highest and the lowest Gross enrolment ratio (%) in Primary schools?
Provide a succinct answer. 25.54. What is the difference between the highest and the lowest Gross enrolment ratio (%) of Secondary schools?
Ensure brevity in your answer.  3.34. What is the difference between the highest and the lowest Gross enrolment ratio (%) of Tertiary schools?
Ensure brevity in your answer.  1.28. 